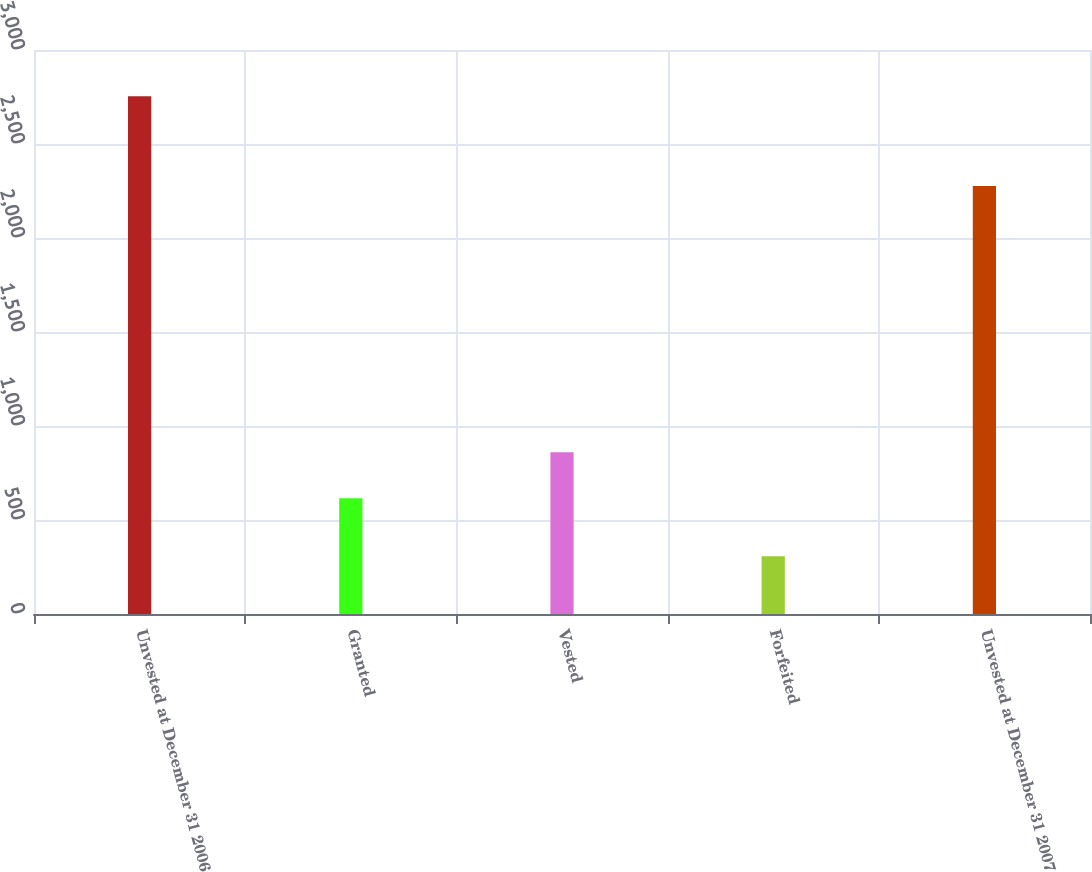Convert chart to OTSL. <chart><loc_0><loc_0><loc_500><loc_500><bar_chart><fcel>Unvested at December 31 2006<fcel>Granted<fcel>Vested<fcel>Forfeited<fcel>Unvested at December 31 2007<nl><fcel>2754<fcel>616<fcel>860.7<fcel>307<fcel>2277<nl></chart> 